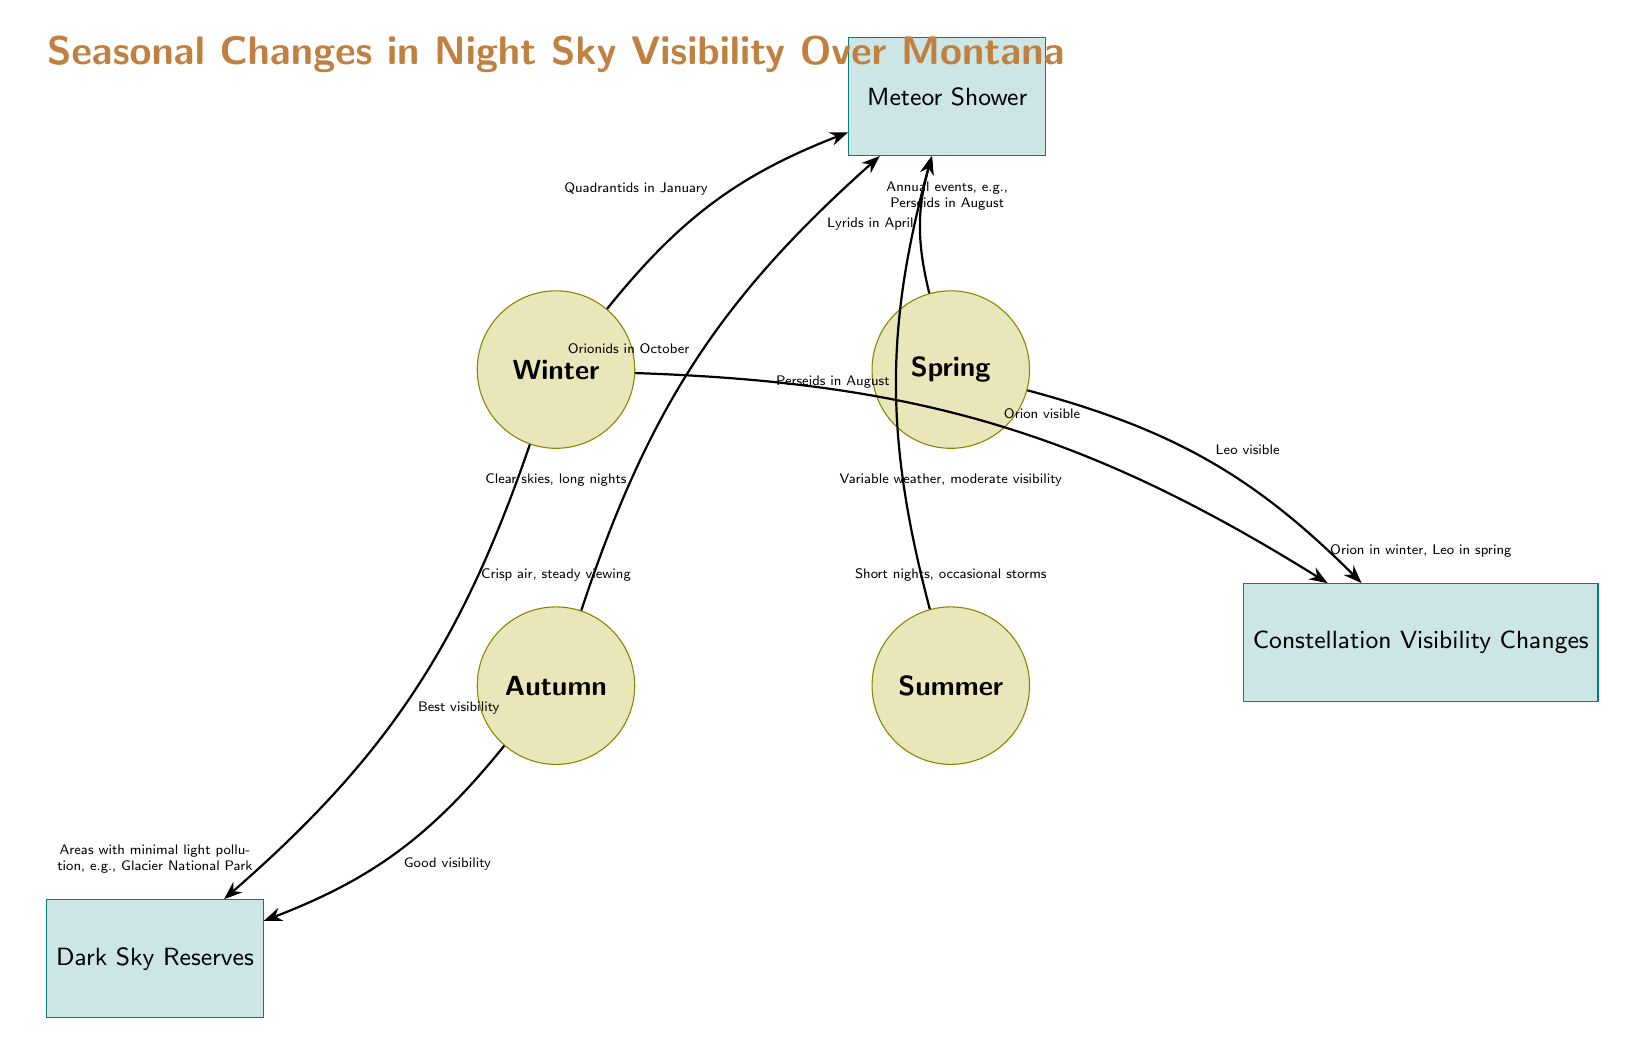What meteor shower is associated with winter? The diagram shows an arrow from the winter season node to the meteor shower node indicating the association. The label on that arrow specifies "Quadrantids in January," which identifies the meteor shower in winter.
Answer: Quadrantids Which season has the best visibility noted in the diagram? In the diagram, the winter season is connected to the "Best visibility" label under the dark sky reserves node. This indicates that winter is noted for its optimal viewing conditions.
Answer: Winter How many meteor showers are listed in the diagram? To answer this, I count the number of arrows going from the seasonal nodes to the meteor shower node. The diagram shows four separate arrows for the Quadrantids, Lyrids, Perseids, and Orionids, indicating there are four meteor showers listed.
Answer: 4 What constellation is visible in spring? According to the diagram, there is an arrow labeled "Leo visible" pointing from the spring season node to the constellation node. This clearly indicates that Leo is the constellation visible in spring.
Answer: Leo Which season is associated with dark sky reserves? The diagram shows connections from the winter and autumn season nodes to the dark sky reserves node. However, since the question asks for the explicit association related to a season, I check which one has a clearer indication for the dark sky viewing. The best noted connection appears to be from winter.
Answer: Winter 